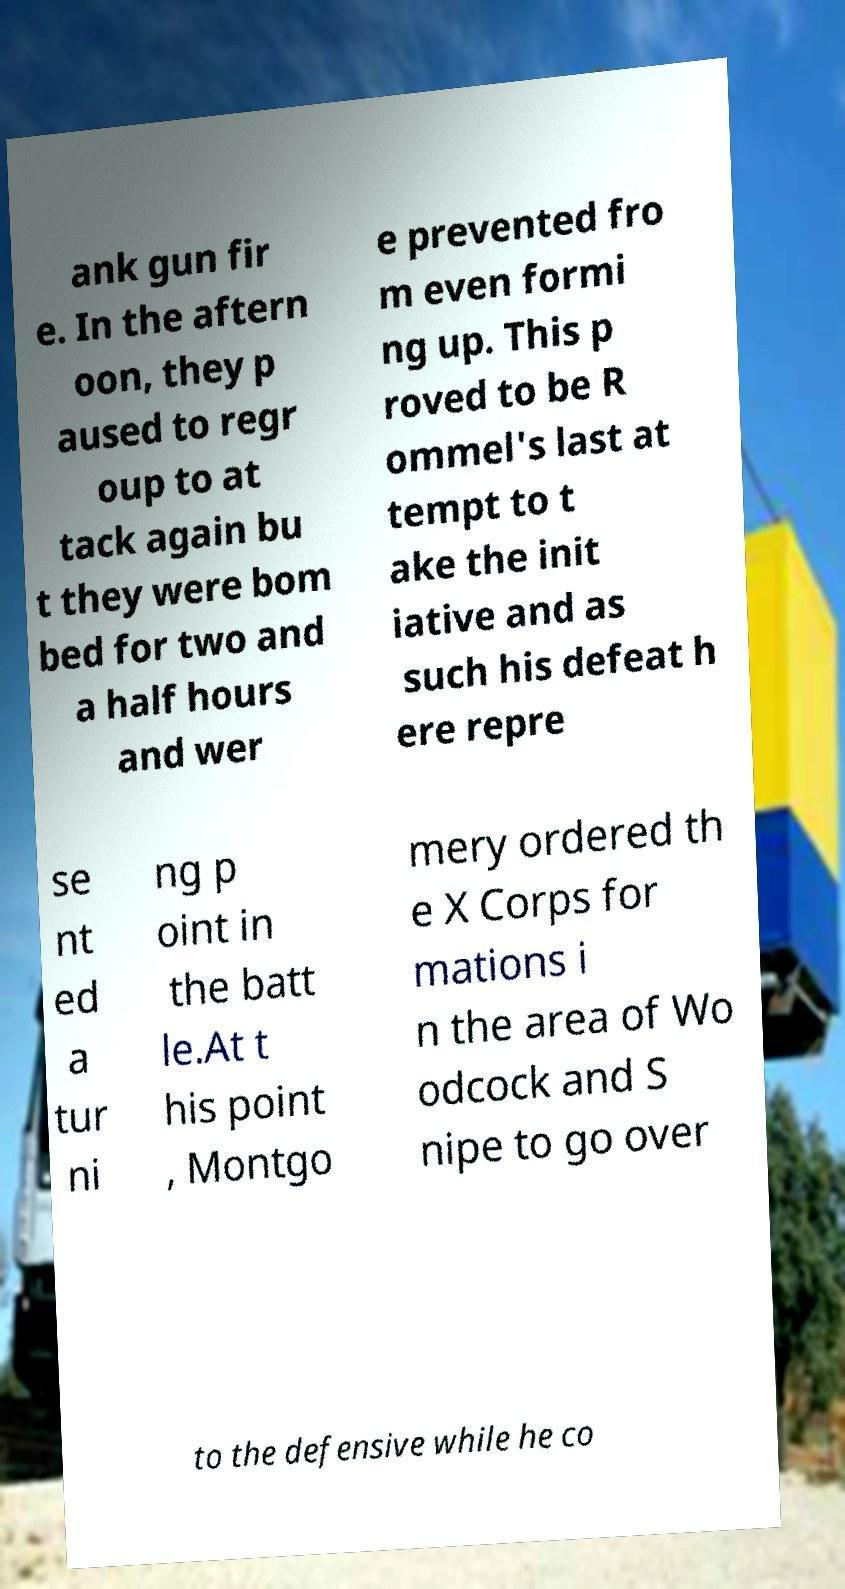Could you assist in decoding the text presented in this image and type it out clearly? ank gun fir e. In the aftern oon, they p aused to regr oup to at tack again bu t they were bom bed for two and a half hours and wer e prevented fro m even formi ng up. This p roved to be R ommel's last at tempt to t ake the init iative and as such his defeat h ere repre se nt ed a tur ni ng p oint in the batt le.At t his point , Montgo mery ordered th e X Corps for mations i n the area of Wo odcock and S nipe to go over to the defensive while he co 